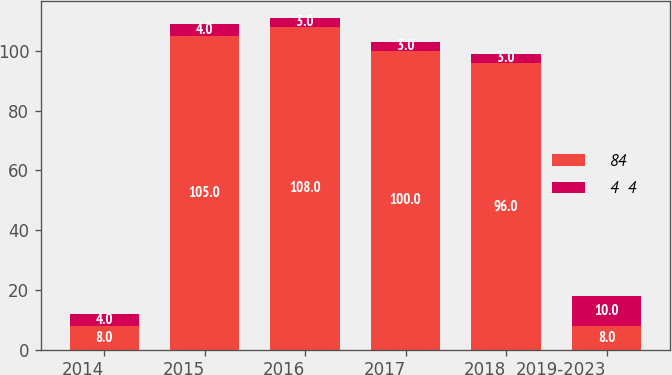Convert chart to OTSL. <chart><loc_0><loc_0><loc_500><loc_500><stacked_bar_chart><ecel><fcel>2014<fcel>2015<fcel>2016<fcel>2017<fcel>2018<fcel>2019-2023<nl><fcel>84<fcel>8<fcel>105<fcel>108<fcel>100<fcel>96<fcel>8<nl><fcel>4  4<fcel>4<fcel>4<fcel>3<fcel>3<fcel>3<fcel>10<nl></chart> 